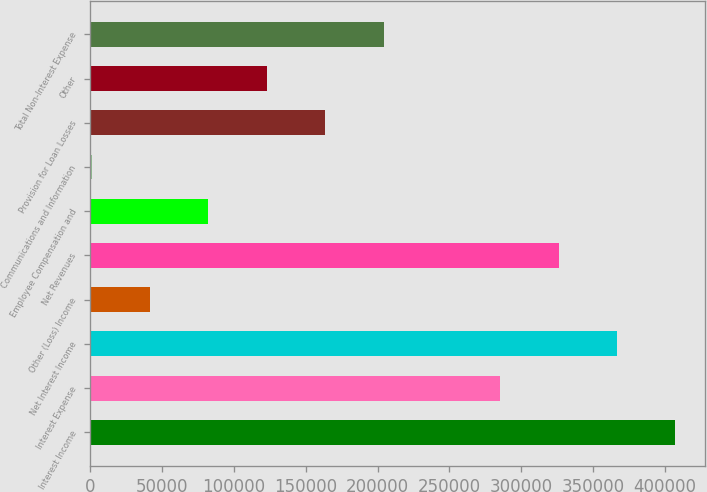Convert chart. <chart><loc_0><loc_0><loc_500><loc_500><bar_chart><fcel>Interest Income<fcel>Interest Expense<fcel>Net Interest Income<fcel>Other (Loss) Income<fcel>Net Revenues<fcel>Employee Compensation and<fcel>Communications and Information<fcel>Provision for Loan Losses<fcel>Other<fcel>Total Non-Interest Expense<nl><fcel>407123<fcel>285325<fcel>366524<fcel>41729.3<fcel>325924<fcel>82328.6<fcel>1130<fcel>163527<fcel>122928<fcel>204126<nl></chart> 